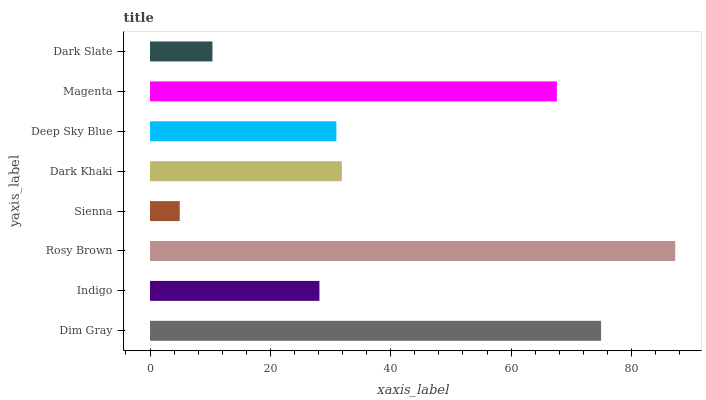Is Sienna the minimum?
Answer yes or no. Yes. Is Rosy Brown the maximum?
Answer yes or no. Yes. Is Indigo the minimum?
Answer yes or no. No. Is Indigo the maximum?
Answer yes or no. No. Is Dim Gray greater than Indigo?
Answer yes or no. Yes. Is Indigo less than Dim Gray?
Answer yes or no. Yes. Is Indigo greater than Dim Gray?
Answer yes or no. No. Is Dim Gray less than Indigo?
Answer yes or no. No. Is Dark Khaki the high median?
Answer yes or no. Yes. Is Deep Sky Blue the low median?
Answer yes or no. Yes. Is Sienna the high median?
Answer yes or no. No. Is Magenta the low median?
Answer yes or no. No. 